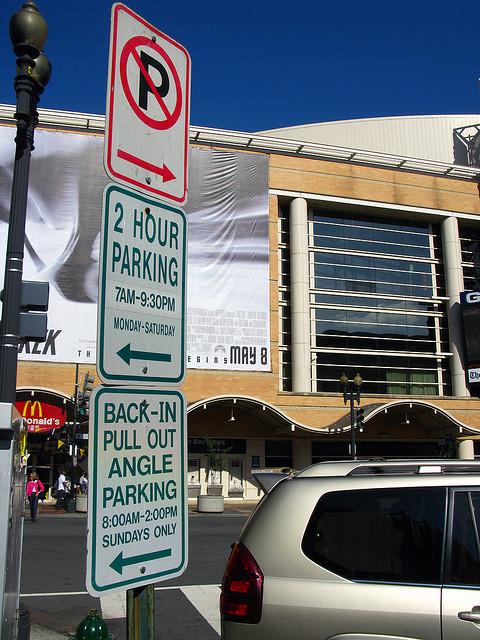Is it parallel parking?
Keep it brief. No. What color is the lettering on the bottom sign?
Write a very short answer. Green. How many hours can a person park for?
Concise answer only. 2. 